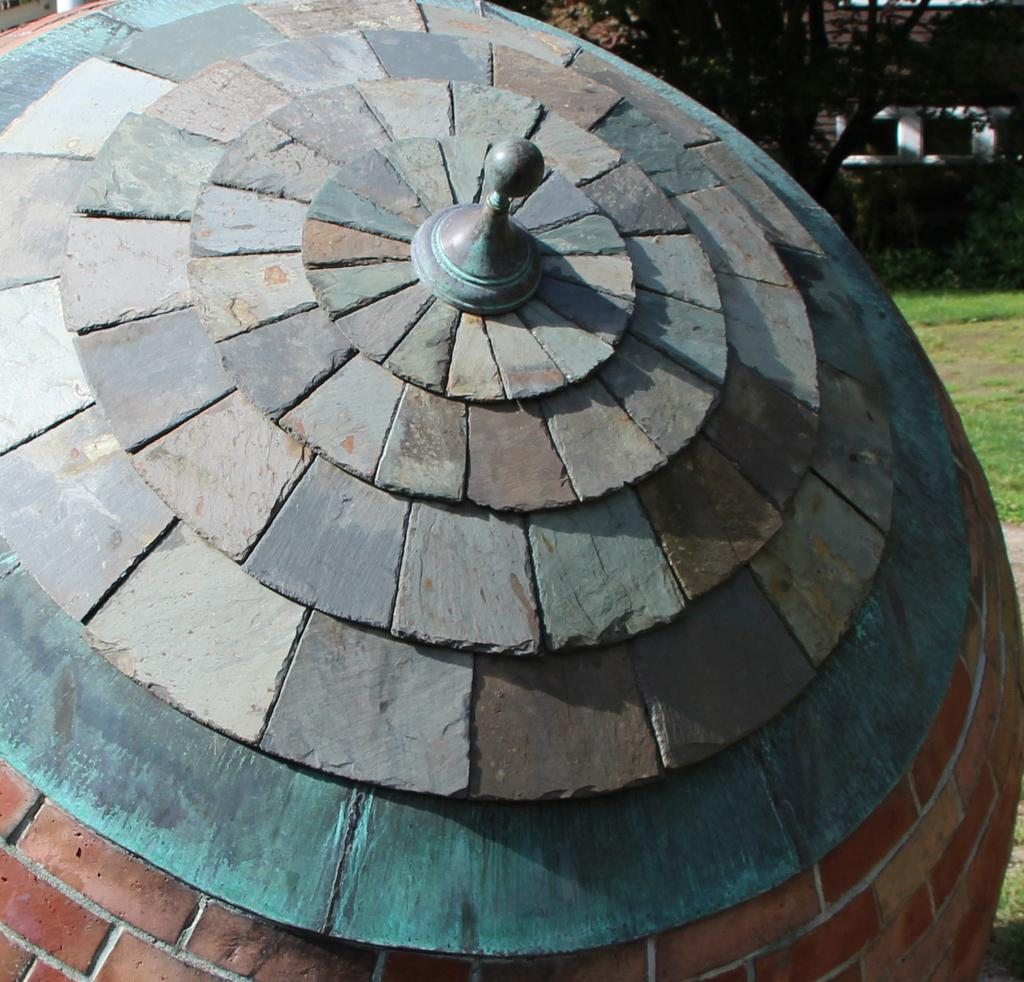What type of architecture is featured in the image? There is a dome-shaped architecture in the image. What material is the architecture made of? The architecture is made of bricks. What can be seen in the background of the image? There are trees and a building in the background of the image. What is the ground covered with in the image? There is grass on the ground in the image. Can you see a friend holding a balloon near the yak in the image? There is no friend, balloon, or yak present in the image. 